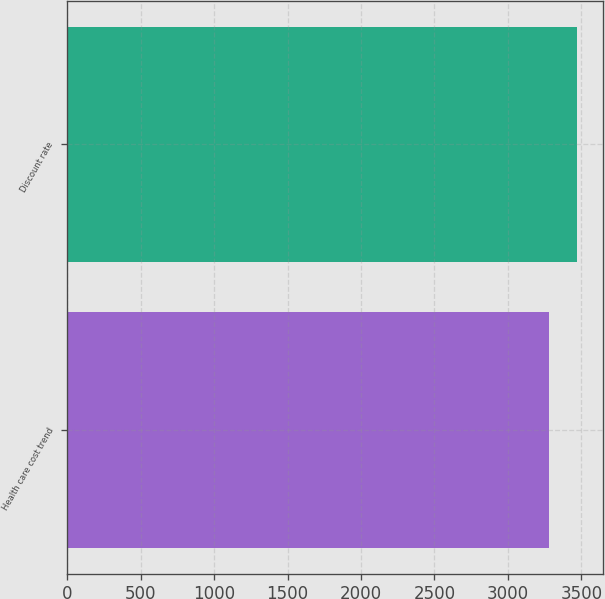<chart> <loc_0><loc_0><loc_500><loc_500><bar_chart><fcel>Health care cost trend<fcel>Discount rate<nl><fcel>3280<fcel>3474<nl></chart> 